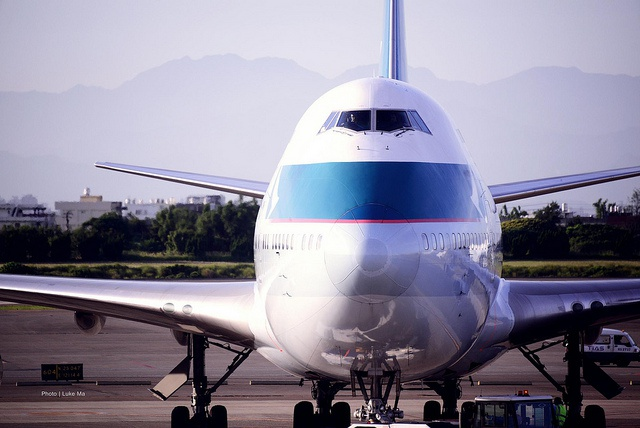Describe the objects in this image and their specific colors. I can see airplane in darkgray, white, black, and gray tones, truck in darkgray, black, gray, and navy tones, truck in darkgray, black, purple, navy, and gray tones, people in darkgray, navy, and gray tones, and people in black and darkgray tones in this image. 